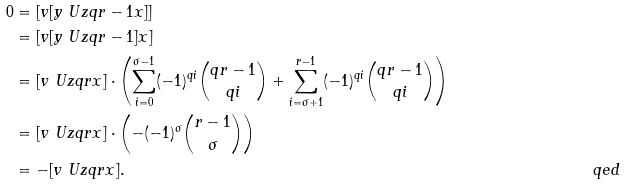<formula> <loc_0><loc_0><loc_500><loc_500>0 & = [ v [ y \ U { z } { q r - 1 } x ] ] \\ & = [ v [ y \ U { z } { q r - 1 } ] x ] \\ & = [ v \ U { z } { q r } x ] \cdot \left ( \sum _ { i = 0 } ^ { \sigma - 1 } ( - 1 ) ^ { q i } \binom { q r - 1 } { q i } + \sum _ { i = \sigma + 1 } ^ { r - 1 } ( - 1 ) ^ { q i } \binom { q r - 1 } { q i } \right ) \\ & = [ v \ U { z } { q r } x ] \cdot \left ( - ( - 1 ) ^ { \sigma } \binom { r - 1 } { \sigma } \right ) \\ & = - [ v \ U { z } { q r } x ] . & & \ q e d</formula> 